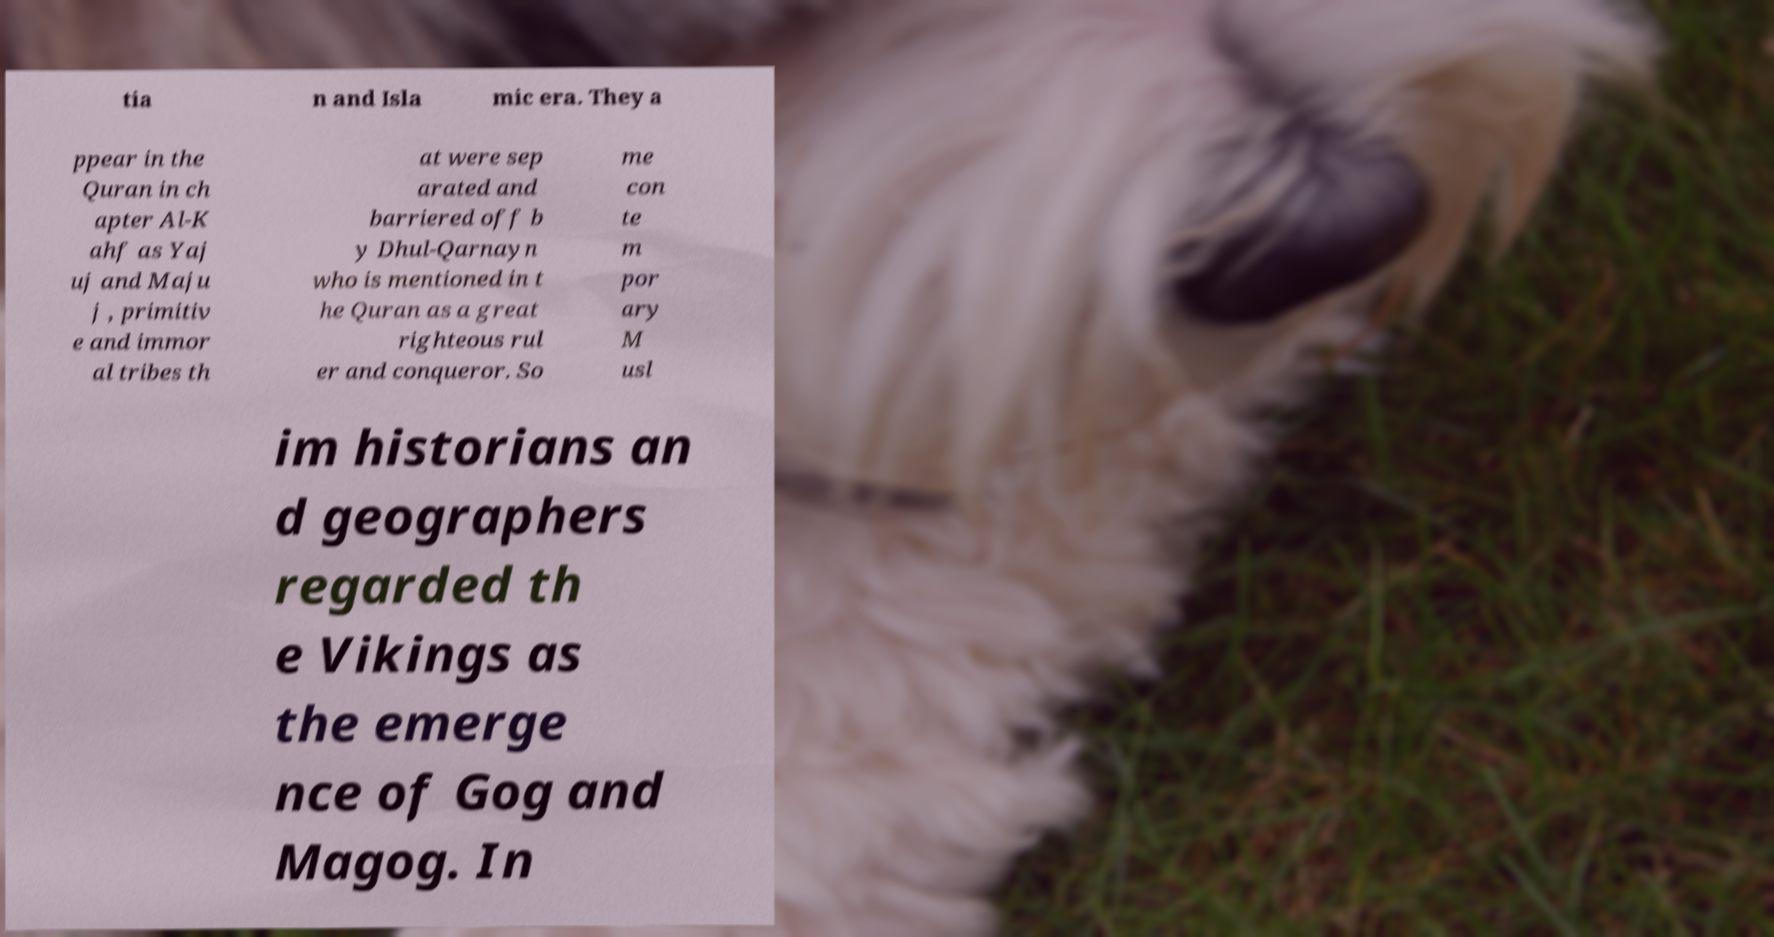Please identify and transcribe the text found in this image. tia n and Isla mic era. They a ppear in the Quran in ch apter Al-K ahf as Yaj uj and Maju j , primitiv e and immor al tribes th at were sep arated and barriered off b y Dhul-Qarnayn who is mentioned in t he Quran as a great righteous rul er and conqueror. So me con te m por ary M usl im historians an d geographers regarded th e Vikings as the emerge nce of Gog and Magog. In 